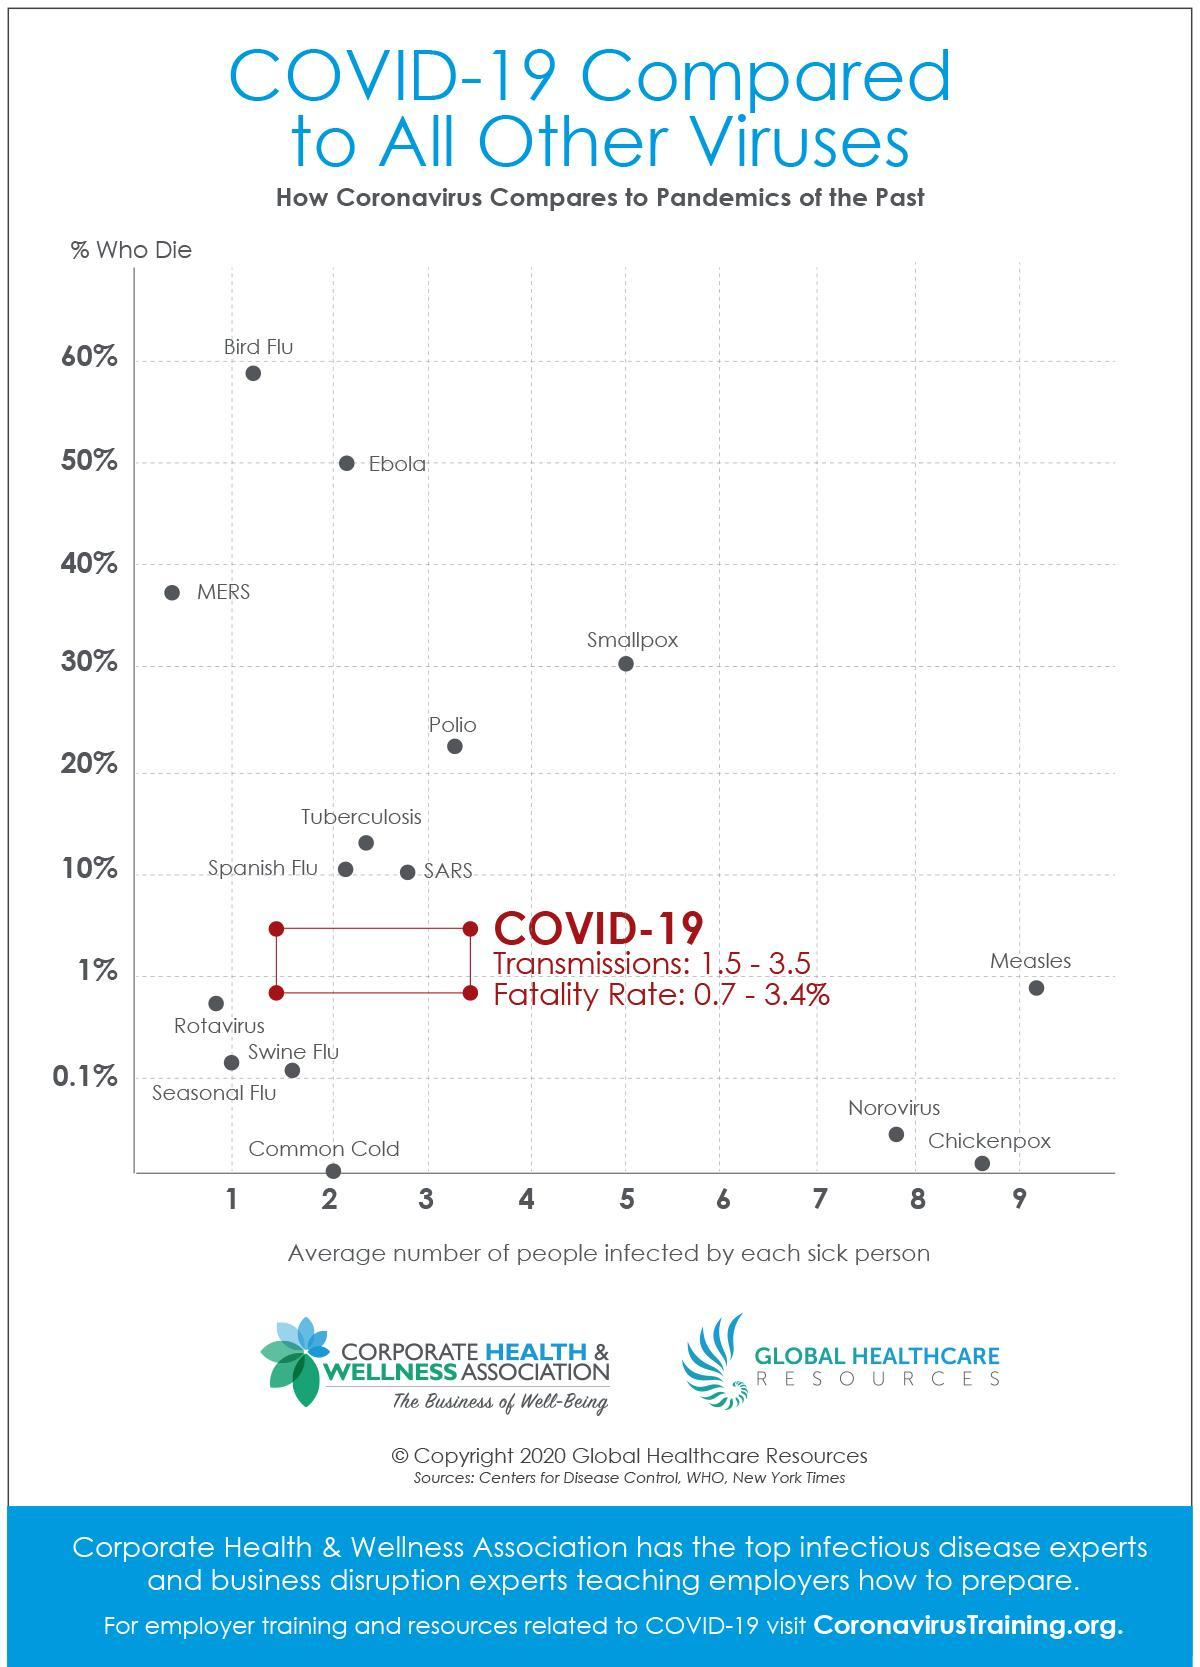Name the disease whose fatality rate is 0%.
Answer the question with a short phrase. Common Cold Name the most contagious disease given in the graph. Measles Which diseases cause 50% or more deaths? Ebola, Bird Flu As per the graph which is the most deadly disease? Bird Flu As per the graph which is the second most deadly disease? Ebola Name the diseases and viruses that are less than 0.1% deadly. Common Cold, Norovirus, Chickenpox As per the graph which are the three most contagious diseases? Norovirus, Chickenpox, Measles A person infected with which disease can spread it to more than two persons and the survival rate is only half? Ebola 